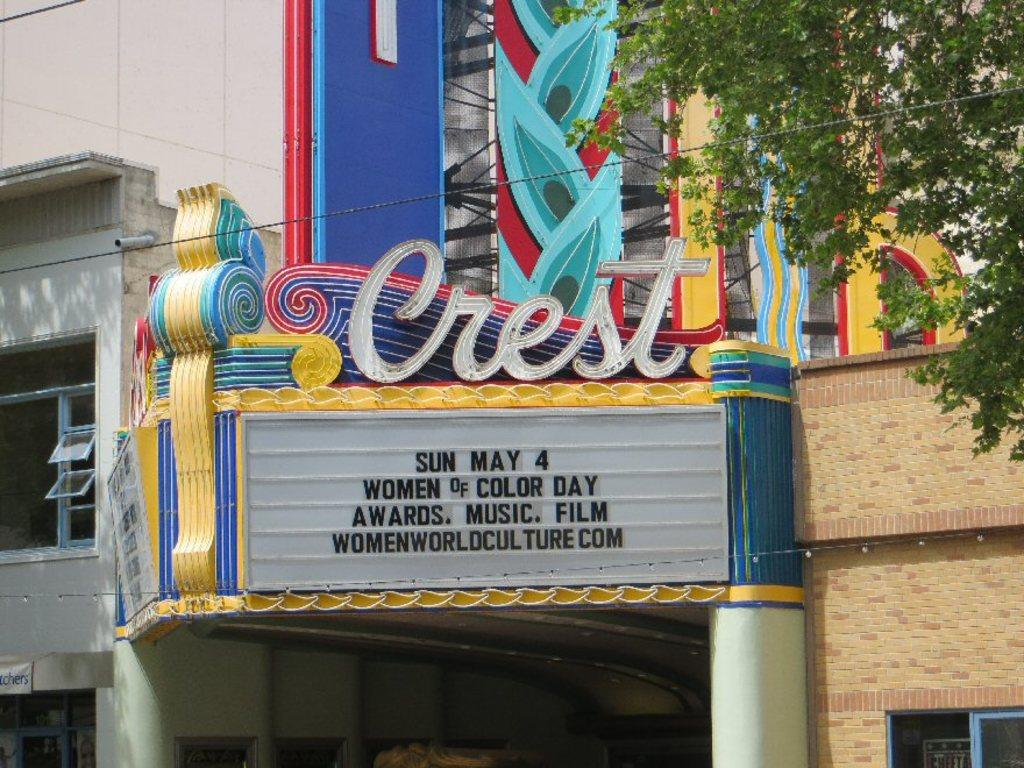What type of structure is present in the image? There is a building in the image. Can you describe any specific features of the building? The building has a name board attached to the wall. What can be seen on the right side of the image? There is a tree on the right side of the image. What is located in the middle of the image? There is a wire in the middle of the image. What else can be seen in the background of the image? There is another building visible in the background of the image. Where is the sofa located in the image? There is no sofa present in the image. What type of table can be seen in the image? There is no table present in the image. 